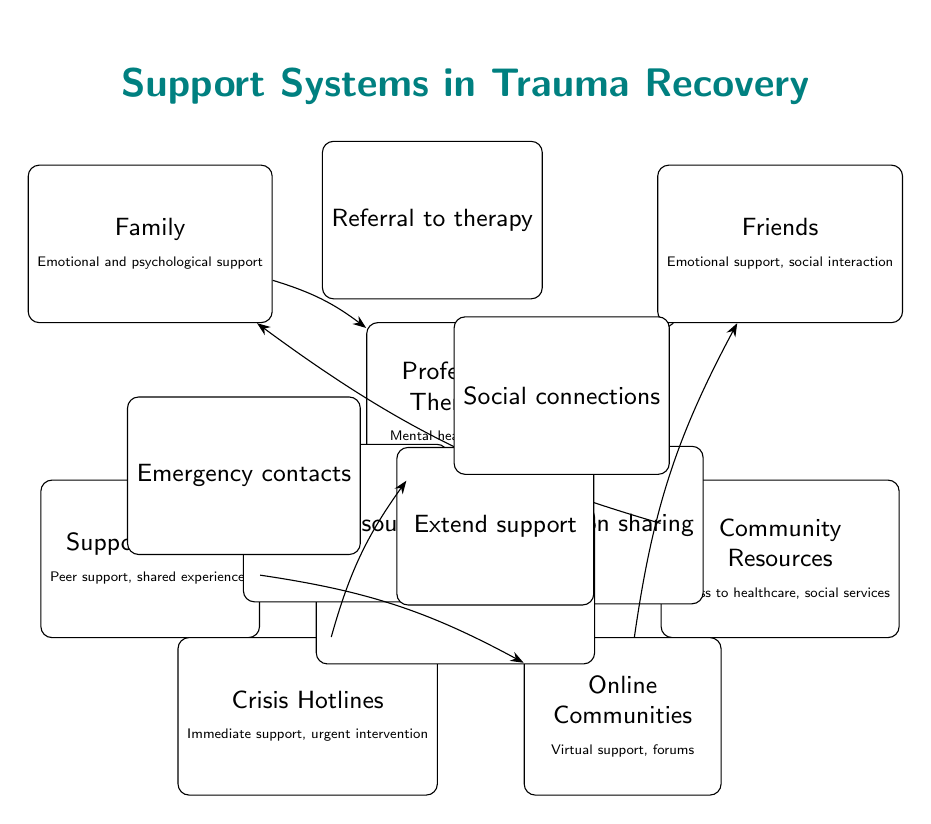What is the role of Family in the recovery process? The diagram indicates that the role of Family is to provide emotional and psychological support, as shown in the node labeled "Family". This is a direct statement of the support function attributed to Family.
Answer: Emotional and psychological support How many nodes are present in the diagram? By counting the nodes visually, we find that there are a total of seven nodes, which represent various support systems in trauma recovery.
Answer: 7 What type of support do Online Communities offer? The diagram specifies that Online Communities offer virtual support and forums, indicating their role as a source of assistive interactions for those recovering from trauma.
Answer: Virtual support, forums Which node shares information primarily with Support Groups? The diagram shows that Friends provide information sharing to Support Groups, as indicated by the connecting arrow and the label explaining the relationship.
Answer: Friends How do Community Resources contribute to Family support? Community Resources provide resources to Family, as depicted in the diagram. The arrow directed from Community Resources to Family indicates this specific contribution to the family support dynamic.
Answer: Provide resources What connects Therapists to Support Groups? The diagram demonstrates that Therapists recommend groups to Support Groups, making that the direct connection indicated by the arrow between these two nodes.
Answer: Group recommendations Which type of support is provided by Crisis Hotlines? The diagram identifies that Crisis Hotlines offer immediate support and urgent intervention, specifying the nature of assistance they provide in trauma recovery scenarios.
Answer: Immediate support, urgent intervention What is the interconnection between Support Groups and Online Communities? The diagram illustrates that Support Groups extend support to Online Communities, showing a direct relationship where Support Groups feed into the online support framework.
Answer: Extend support What is the connection between Hotlines and Therapists? The diagram indicates that Hotlines serve as emergency contacts for Therapists, outlining their relationship in helping individuals in crisis situations.
Answer: Emergency contacts 